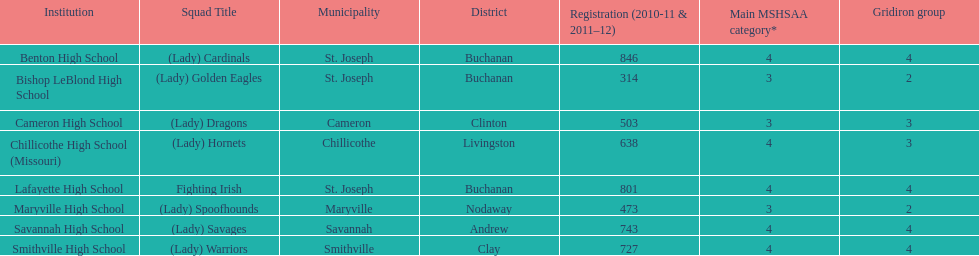Does lafayette high school or benton high school have green and grey as their colors? Lafayette High School. 